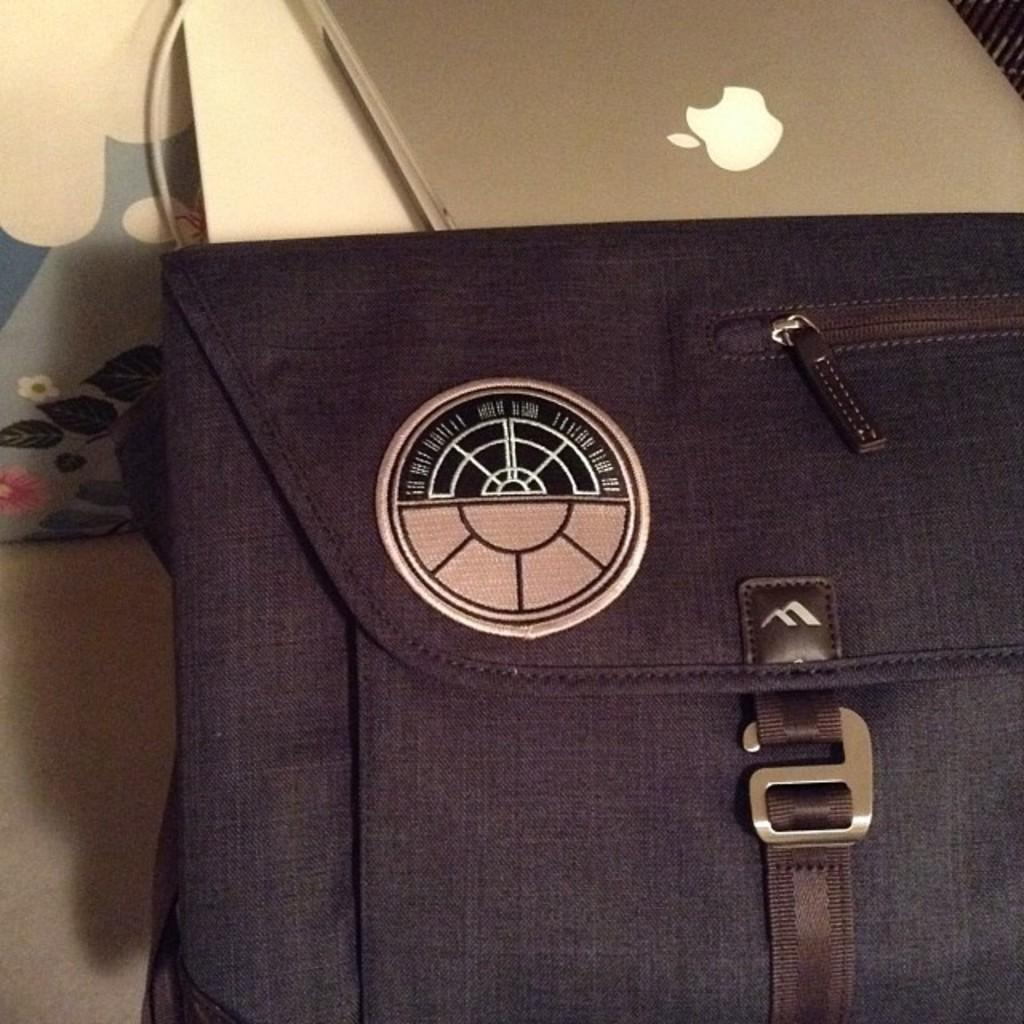What object can be seen in the image? There is a purse in the image. What can be seen in the background of the image? There is a laptop, an electric wire, and a paper in the background of the image. How many yams are on the sofa in the image? There are no yams or sofa present in the image. How many legs does the purse have in the image? The purse is a single object and does not have legs. 